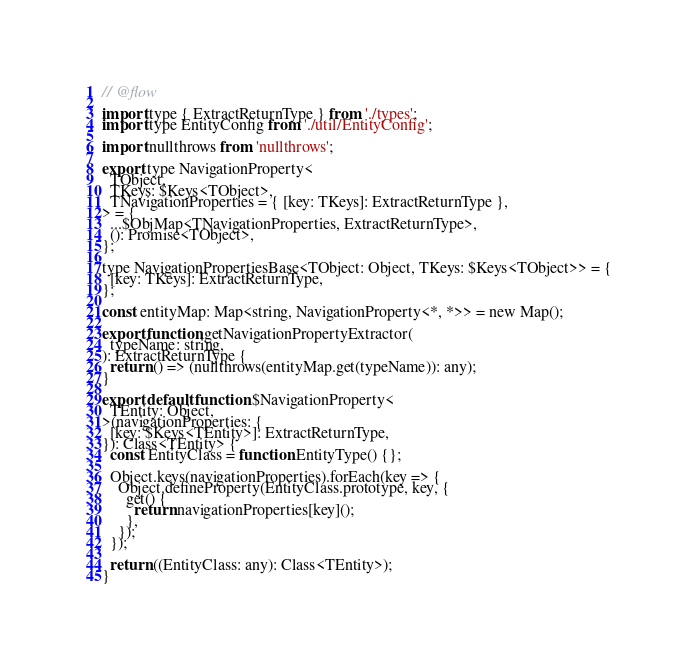Convert code to text. <code><loc_0><loc_0><loc_500><loc_500><_JavaScript_>// @flow

import type { ExtractReturnType } from './types';
import type EntityConfig from './util/EntityConfig';

import nullthrows from 'nullthrows';

export type NavigationProperty<
  TObject,
  TKeys: $Keys<TObject>,
  TNavigationProperties = { [key: TKeys]: ExtractReturnType },
> = {
  ...$ObjMap<TNavigationProperties, ExtractReturnType>,
  (): Promise<TObject>,
};

type NavigationPropertiesBase<TObject: Object, TKeys: $Keys<TObject>> = {
  [key: TKeys]: ExtractReturnType,
};

const entityMap: Map<string, NavigationProperty<*, *>> = new Map();

export function getNavigationPropertyExtractor(
  typeName: string,
): ExtractReturnType {
  return () => (nullthrows(entityMap.get(typeName)): any);
}

export default function $NavigationProperty<
  TEntity: Object,
>(navigationProperties: {
  [key: $Keys<TEntity>]: ExtractReturnType,
}): Class<TEntity> {
  const EntityClass = function EntityType() {};

  Object.keys(navigationProperties).forEach(key => {
    Object.defineProperty(EntityClass.prototype, key, {
      get() {
        return navigationProperties[key]();
      },
    });
  });

  return ((EntityClass: any): Class<TEntity>);
}
</code> 